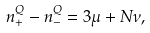<formula> <loc_0><loc_0><loc_500><loc_500>n ^ { Q } _ { + } - n ^ { Q } _ { - } = 3 \mu + N \nu ,</formula> 